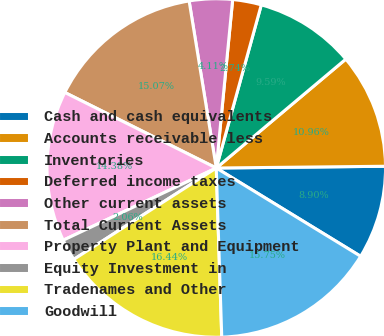Convert chart. <chart><loc_0><loc_0><loc_500><loc_500><pie_chart><fcel>Cash and cash equivalents<fcel>Accounts receivable less<fcel>Inventories<fcel>Deferred income taxes<fcel>Other current assets<fcel>Total Current Assets<fcel>Property Plant and Equipment<fcel>Equity Investment in<fcel>Tradenames and Other<fcel>Goodwill<nl><fcel>8.9%<fcel>10.96%<fcel>9.59%<fcel>2.74%<fcel>4.11%<fcel>15.07%<fcel>14.38%<fcel>2.06%<fcel>16.44%<fcel>15.75%<nl></chart> 